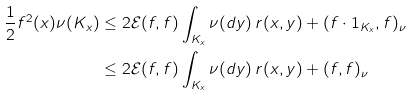<formula> <loc_0><loc_0><loc_500><loc_500>\frac { 1 } { 2 } f ^ { 2 } ( x ) \nu ( K _ { x } ) & \leq 2 { \mathcal { E } } ( f , f ) \int _ { K _ { x } } \nu ( d y ) \, r ( x , y ) + ( f \cdot 1 _ { K _ { x } } , f ) _ { \nu } \\ & \leq 2 { \mathcal { E } } ( f , f ) \int _ { K _ { x } } \nu ( d y ) \, r ( x , y ) + ( f , f ) _ { \nu }</formula> 